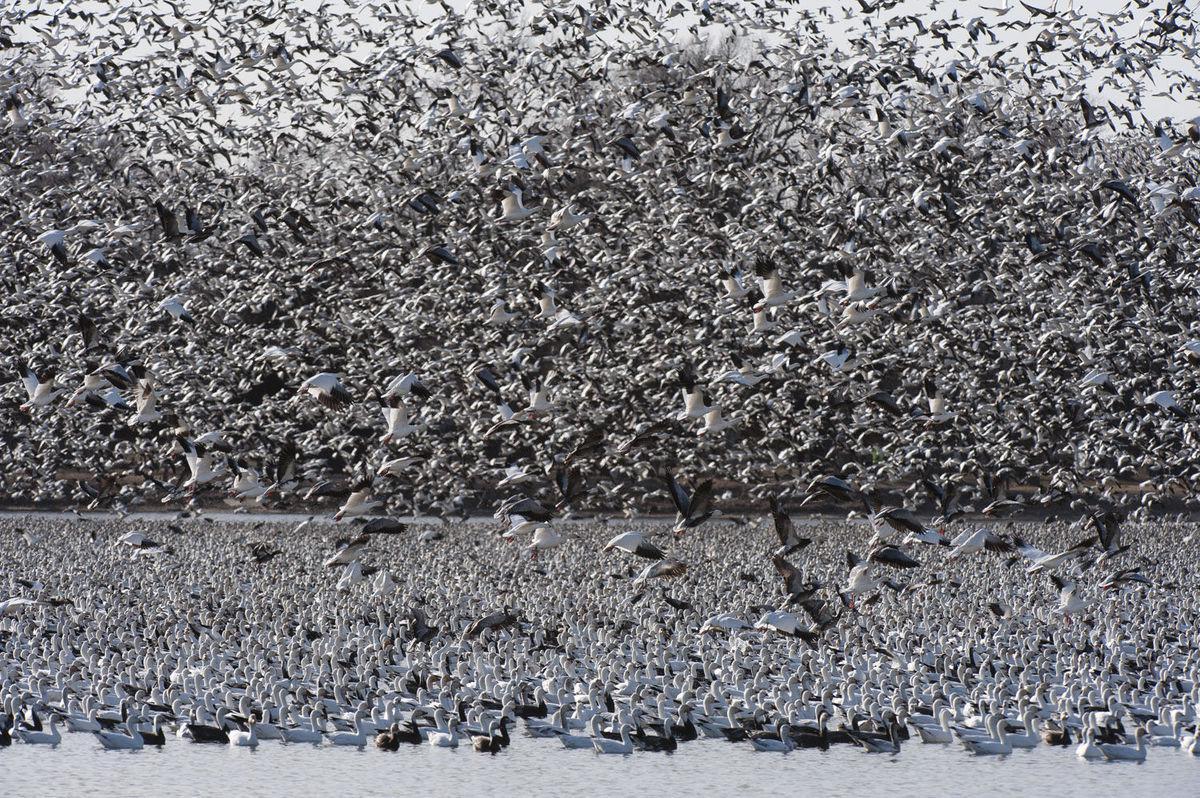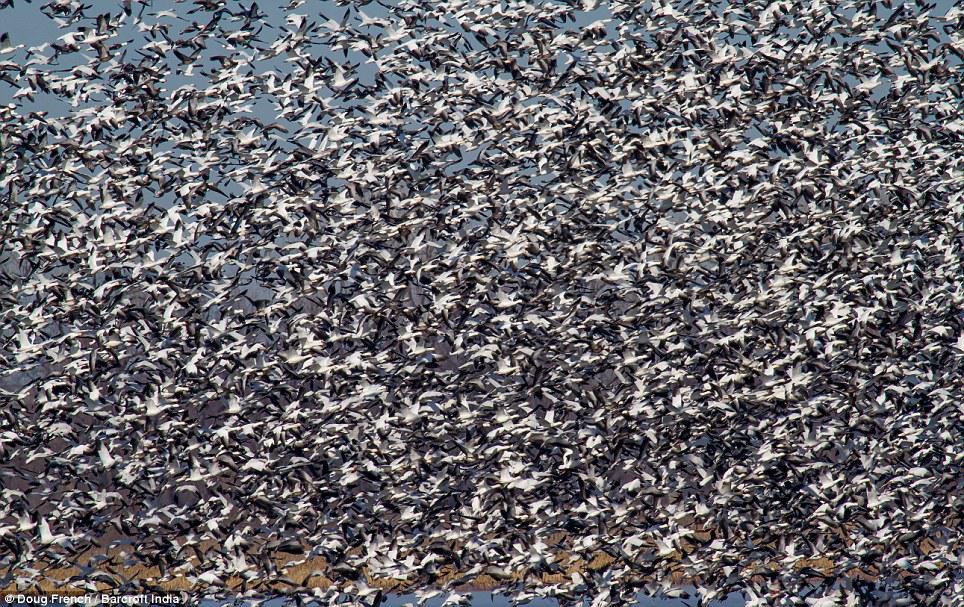The first image is the image on the left, the second image is the image on the right. Evaluate the accuracy of this statement regarding the images: "A body of water is visible below a sky full of birds in at least one image.". Is it true? Answer yes or no. Yes. 